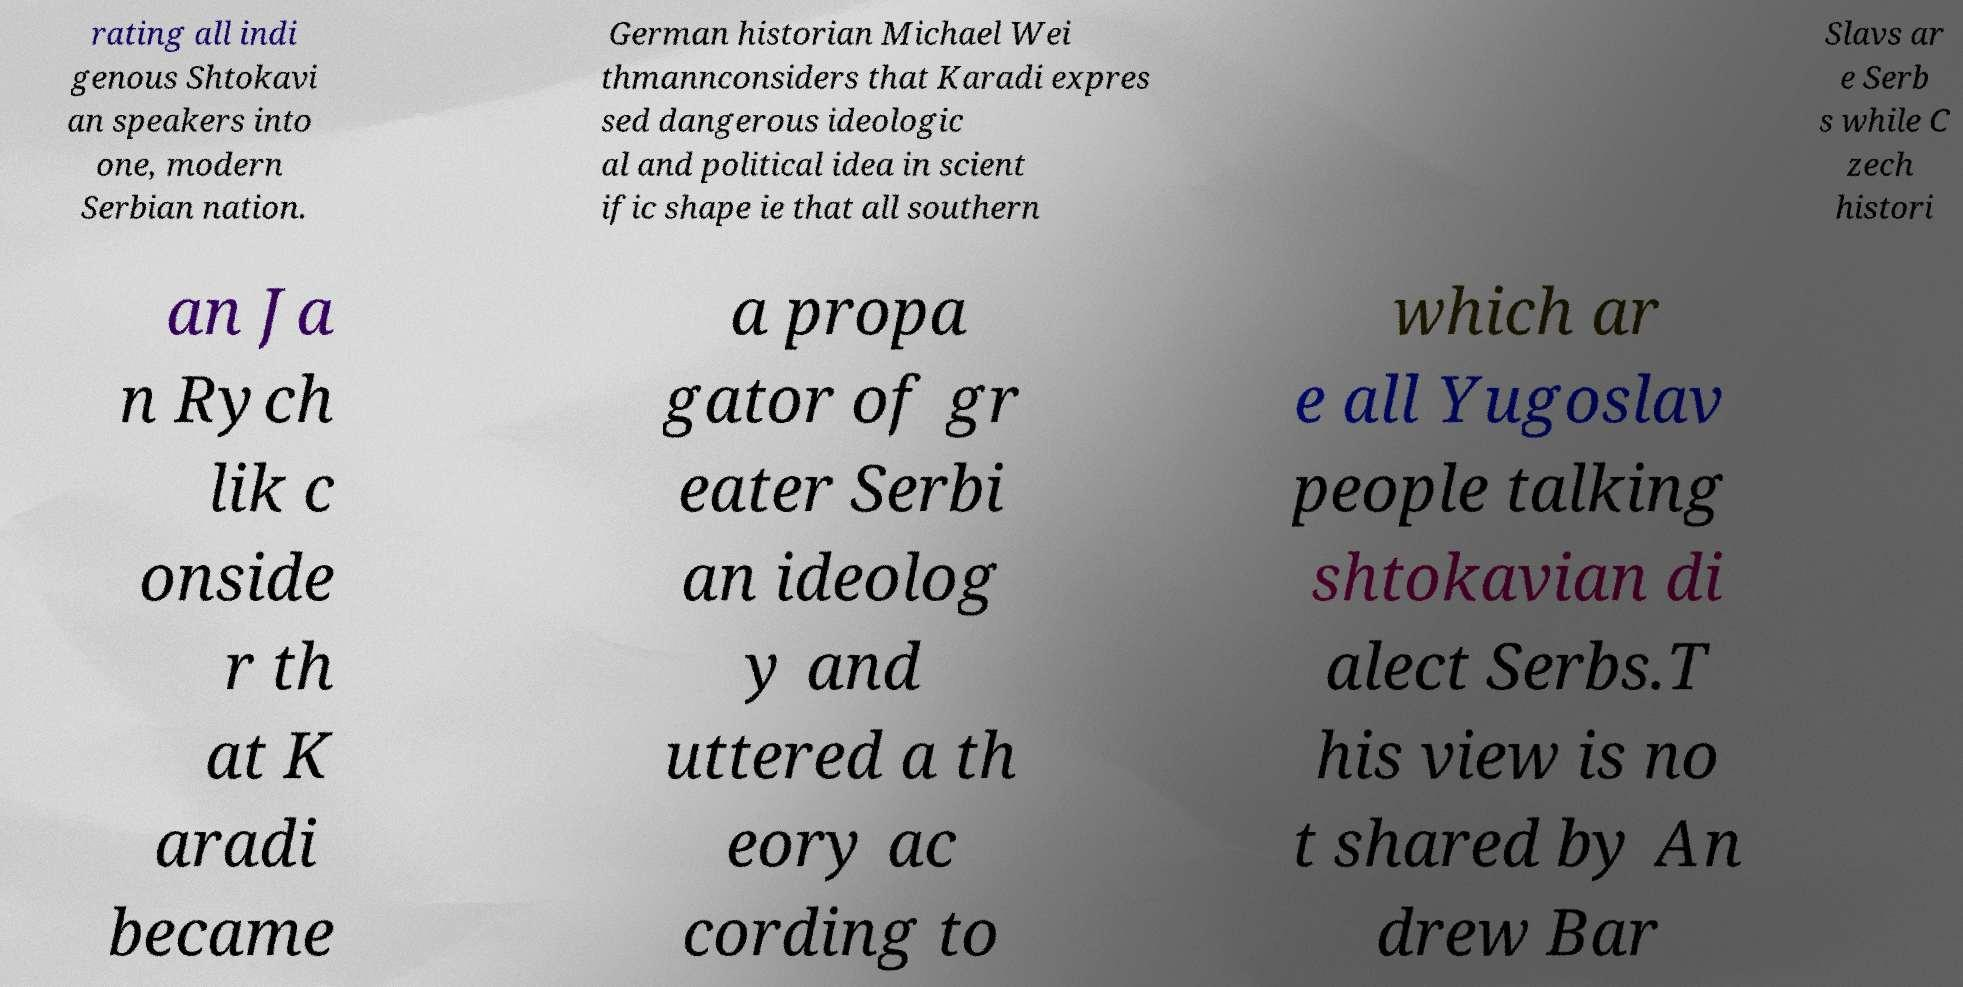There's text embedded in this image that I need extracted. Can you transcribe it verbatim? rating all indi genous Shtokavi an speakers into one, modern Serbian nation. German historian Michael Wei thmannconsiders that Karadi expres sed dangerous ideologic al and political idea in scient ific shape ie that all southern Slavs ar e Serb s while C zech histori an Ja n Rych lik c onside r th at K aradi became a propa gator of gr eater Serbi an ideolog y and uttered a th eory ac cording to which ar e all Yugoslav people talking shtokavian di alect Serbs.T his view is no t shared by An drew Bar 